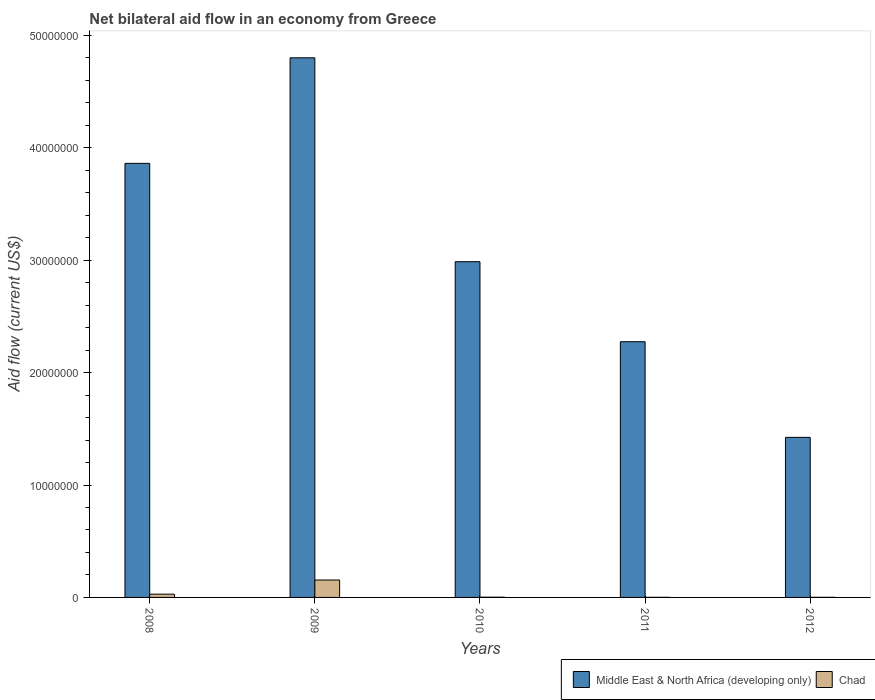How many different coloured bars are there?
Offer a terse response. 2. How many groups of bars are there?
Offer a terse response. 5. Are the number of bars on each tick of the X-axis equal?
Offer a terse response. Yes. How many bars are there on the 3rd tick from the left?
Ensure brevity in your answer.  2. How many bars are there on the 3rd tick from the right?
Make the answer very short. 2. What is the label of the 5th group of bars from the left?
Ensure brevity in your answer.  2012. What is the net bilateral aid flow in Middle East & North Africa (developing only) in 2009?
Your answer should be compact. 4.80e+07. Across all years, what is the maximum net bilateral aid flow in Middle East & North Africa (developing only)?
Your answer should be very brief. 4.80e+07. Across all years, what is the minimum net bilateral aid flow in Chad?
Give a very brief answer. 10000. In which year was the net bilateral aid flow in Middle East & North Africa (developing only) minimum?
Your answer should be very brief. 2012. What is the total net bilateral aid flow in Middle East & North Africa (developing only) in the graph?
Your answer should be compact. 1.53e+08. What is the difference between the net bilateral aid flow in Middle East & North Africa (developing only) in 2010 and that in 2011?
Keep it short and to the point. 7.12e+06. What is the difference between the net bilateral aid flow in Chad in 2008 and the net bilateral aid flow in Middle East & North Africa (developing only) in 2010?
Make the answer very short. -2.96e+07. What is the average net bilateral aid flow in Chad per year?
Provide a short and direct response. 3.76e+05. In the year 2012, what is the difference between the net bilateral aid flow in Chad and net bilateral aid flow in Middle East & North Africa (developing only)?
Ensure brevity in your answer.  -1.42e+07. What is the ratio of the net bilateral aid flow in Chad in 2008 to that in 2010?
Your answer should be very brief. 14.5. Is the net bilateral aid flow in Middle East & North Africa (developing only) in 2008 less than that in 2009?
Your answer should be very brief. Yes. What is the difference between the highest and the second highest net bilateral aid flow in Middle East & North Africa (developing only)?
Keep it short and to the point. 9.39e+06. What is the difference between the highest and the lowest net bilateral aid flow in Middle East & North Africa (developing only)?
Ensure brevity in your answer.  3.38e+07. What does the 1st bar from the left in 2012 represents?
Provide a succinct answer. Middle East & North Africa (developing only). What does the 1st bar from the right in 2009 represents?
Make the answer very short. Chad. How many bars are there?
Offer a terse response. 10. Are the values on the major ticks of Y-axis written in scientific E-notation?
Your answer should be compact. No. Does the graph contain any zero values?
Your answer should be compact. No. What is the title of the graph?
Give a very brief answer. Net bilateral aid flow in an economy from Greece. Does "Sierra Leone" appear as one of the legend labels in the graph?
Offer a very short reply. No. What is the label or title of the X-axis?
Your response must be concise. Years. What is the Aid flow (current US$) in Middle East & North Africa (developing only) in 2008?
Keep it short and to the point. 3.86e+07. What is the Aid flow (current US$) of Chad in 2008?
Offer a very short reply. 2.90e+05. What is the Aid flow (current US$) in Middle East & North Africa (developing only) in 2009?
Your answer should be very brief. 4.80e+07. What is the Aid flow (current US$) of Chad in 2009?
Make the answer very short. 1.55e+06. What is the Aid flow (current US$) in Middle East & North Africa (developing only) in 2010?
Keep it short and to the point. 2.99e+07. What is the Aid flow (current US$) in Chad in 2010?
Ensure brevity in your answer.  2.00e+04. What is the Aid flow (current US$) in Middle East & North Africa (developing only) in 2011?
Make the answer very short. 2.28e+07. What is the Aid flow (current US$) in Middle East & North Africa (developing only) in 2012?
Make the answer very short. 1.42e+07. Across all years, what is the maximum Aid flow (current US$) in Middle East & North Africa (developing only)?
Offer a terse response. 4.80e+07. Across all years, what is the maximum Aid flow (current US$) in Chad?
Ensure brevity in your answer.  1.55e+06. Across all years, what is the minimum Aid flow (current US$) in Middle East & North Africa (developing only)?
Keep it short and to the point. 1.42e+07. What is the total Aid flow (current US$) of Middle East & North Africa (developing only) in the graph?
Your response must be concise. 1.53e+08. What is the total Aid flow (current US$) in Chad in the graph?
Provide a short and direct response. 1.88e+06. What is the difference between the Aid flow (current US$) in Middle East & North Africa (developing only) in 2008 and that in 2009?
Your response must be concise. -9.39e+06. What is the difference between the Aid flow (current US$) of Chad in 2008 and that in 2009?
Give a very brief answer. -1.26e+06. What is the difference between the Aid flow (current US$) of Middle East & North Africa (developing only) in 2008 and that in 2010?
Give a very brief answer. 8.75e+06. What is the difference between the Aid flow (current US$) in Chad in 2008 and that in 2010?
Provide a short and direct response. 2.70e+05. What is the difference between the Aid flow (current US$) in Middle East & North Africa (developing only) in 2008 and that in 2011?
Give a very brief answer. 1.59e+07. What is the difference between the Aid flow (current US$) of Chad in 2008 and that in 2011?
Offer a terse response. 2.80e+05. What is the difference between the Aid flow (current US$) in Middle East & North Africa (developing only) in 2008 and that in 2012?
Your response must be concise. 2.44e+07. What is the difference between the Aid flow (current US$) of Middle East & North Africa (developing only) in 2009 and that in 2010?
Provide a short and direct response. 1.81e+07. What is the difference between the Aid flow (current US$) of Chad in 2009 and that in 2010?
Give a very brief answer. 1.53e+06. What is the difference between the Aid flow (current US$) in Middle East & North Africa (developing only) in 2009 and that in 2011?
Your answer should be compact. 2.53e+07. What is the difference between the Aid flow (current US$) in Chad in 2009 and that in 2011?
Your answer should be very brief. 1.54e+06. What is the difference between the Aid flow (current US$) in Middle East & North Africa (developing only) in 2009 and that in 2012?
Give a very brief answer. 3.38e+07. What is the difference between the Aid flow (current US$) of Chad in 2009 and that in 2012?
Ensure brevity in your answer.  1.54e+06. What is the difference between the Aid flow (current US$) in Middle East & North Africa (developing only) in 2010 and that in 2011?
Keep it short and to the point. 7.12e+06. What is the difference between the Aid flow (current US$) of Chad in 2010 and that in 2011?
Your answer should be compact. 10000. What is the difference between the Aid flow (current US$) in Middle East & North Africa (developing only) in 2010 and that in 2012?
Keep it short and to the point. 1.56e+07. What is the difference between the Aid flow (current US$) of Middle East & North Africa (developing only) in 2011 and that in 2012?
Your answer should be very brief. 8.51e+06. What is the difference between the Aid flow (current US$) of Chad in 2011 and that in 2012?
Offer a very short reply. 0. What is the difference between the Aid flow (current US$) of Middle East & North Africa (developing only) in 2008 and the Aid flow (current US$) of Chad in 2009?
Provide a succinct answer. 3.71e+07. What is the difference between the Aid flow (current US$) in Middle East & North Africa (developing only) in 2008 and the Aid flow (current US$) in Chad in 2010?
Give a very brief answer. 3.86e+07. What is the difference between the Aid flow (current US$) of Middle East & North Africa (developing only) in 2008 and the Aid flow (current US$) of Chad in 2011?
Provide a succinct answer. 3.86e+07. What is the difference between the Aid flow (current US$) of Middle East & North Africa (developing only) in 2008 and the Aid flow (current US$) of Chad in 2012?
Offer a very short reply. 3.86e+07. What is the difference between the Aid flow (current US$) of Middle East & North Africa (developing only) in 2009 and the Aid flow (current US$) of Chad in 2010?
Offer a terse response. 4.80e+07. What is the difference between the Aid flow (current US$) in Middle East & North Africa (developing only) in 2009 and the Aid flow (current US$) in Chad in 2011?
Give a very brief answer. 4.80e+07. What is the difference between the Aid flow (current US$) in Middle East & North Africa (developing only) in 2009 and the Aid flow (current US$) in Chad in 2012?
Make the answer very short. 4.80e+07. What is the difference between the Aid flow (current US$) in Middle East & North Africa (developing only) in 2010 and the Aid flow (current US$) in Chad in 2011?
Your response must be concise. 2.99e+07. What is the difference between the Aid flow (current US$) of Middle East & North Africa (developing only) in 2010 and the Aid flow (current US$) of Chad in 2012?
Provide a short and direct response. 2.99e+07. What is the difference between the Aid flow (current US$) of Middle East & North Africa (developing only) in 2011 and the Aid flow (current US$) of Chad in 2012?
Your answer should be very brief. 2.27e+07. What is the average Aid flow (current US$) of Middle East & North Africa (developing only) per year?
Provide a short and direct response. 3.07e+07. What is the average Aid flow (current US$) in Chad per year?
Offer a very short reply. 3.76e+05. In the year 2008, what is the difference between the Aid flow (current US$) of Middle East & North Africa (developing only) and Aid flow (current US$) of Chad?
Ensure brevity in your answer.  3.83e+07. In the year 2009, what is the difference between the Aid flow (current US$) in Middle East & North Africa (developing only) and Aid flow (current US$) in Chad?
Offer a very short reply. 4.65e+07. In the year 2010, what is the difference between the Aid flow (current US$) in Middle East & North Africa (developing only) and Aid flow (current US$) in Chad?
Your answer should be very brief. 2.98e+07. In the year 2011, what is the difference between the Aid flow (current US$) of Middle East & North Africa (developing only) and Aid flow (current US$) of Chad?
Offer a terse response. 2.27e+07. In the year 2012, what is the difference between the Aid flow (current US$) in Middle East & North Africa (developing only) and Aid flow (current US$) in Chad?
Ensure brevity in your answer.  1.42e+07. What is the ratio of the Aid flow (current US$) of Middle East & North Africa (developing only) in 2008 to that in 2009?
Your answer should be compact. 0.8. What is the ratio of the Aid flow (current US$) in Chad in 2008 to that in 2009?
Keep it short and to the point. 0.19. What is the ratio of the Aid flow (current US$) in Middle East & North Africa (developing only) in 2008 to that in 2010?
Offer a terse response. 1.29. What is the ratio of the Aid flow (current US$) in Chad in 2008 to that in 2010?
Your answer should be compact. 14.5. What is the ratio of the Aid flow (current US$) in Middle East & North Africa (developing only) in 2008 to that in 2011?
Ensure brevity in your answer.  1.7. What is the ratio of the Aid flow (current US$) of Middle East & North Africa (developing only) in 2008 to that in 2012?
Offer a very short reply. 2.71. What is the ratio of the Aid flow (current US$) of Middle East & North Africa (developing only) in 2009 to that in 2010?
Keep it short and to the point. 1.61. What is the ratio of the Aid flow (current US$) of Chad in 2009 to that in 2010?
Provide a short and direct response. 77.5. What is the ratio of the Aid flow (current US$) in Middle East & North Africa (developing only) in 2009 to that in 2011?
Ensure brevity in your answer.  2.11. What is the ratio of the Aid flow (current US$) in Chad in 2009 to that in 2011?
Your response must be concise. 155. What is the ratio of the Aid flow (current US$) of Middle East & North Africa (developing only) in 2009 to that in 2012?
Offer a terse response. 3.37. What is the ratio of the Aid flow (current US$) of Chad in 2009 to that in 2012?
Offer a terse response. 155. What is the ratio of the Aid flow (current US$) of Middle East & North Africa (developing only) in 2010 to that in 2011?
Offer a terse response. 1.31. What is the ratio of the Aid flow (current US$) of Middle East & North Africa (developing only) in 2010 to that in 2012?
Give a very brief answer. 2.1. What is the ratio of the Aid flow (current US$) of Chad in 2010 to that in 2012?
Provide a short and direct response. 2. What is the ratio of the Aid flow (current US$) in Middle East & North Africa (developing only) in 2011 to that in 2012?
Provide a short and direct response. 1.6. What is the ratio of the Aid flow (current US$) in Chad in 2011 to that in 2012?
Your answer should be compact. 1. What is the difference between the highest and the second highest Aid flow (current US$) of Middle East & North Africa (developing only)?
Your answer should be compact. 9.39e+06. What is the difference between the highest and the second highest Aid flow (current US$) in Chad?
Keep it short and to the point. 1.26e+06. What is the difference between the highest and the lowest Aid flow (current US$) of Middle East & North Africa (developing only)?
Your response must be concise. 3.38e+07. What is the difference between the highest and the lowest Aid flow (current US$) in Chad?
Offer a terse response. 1.54e+06. 